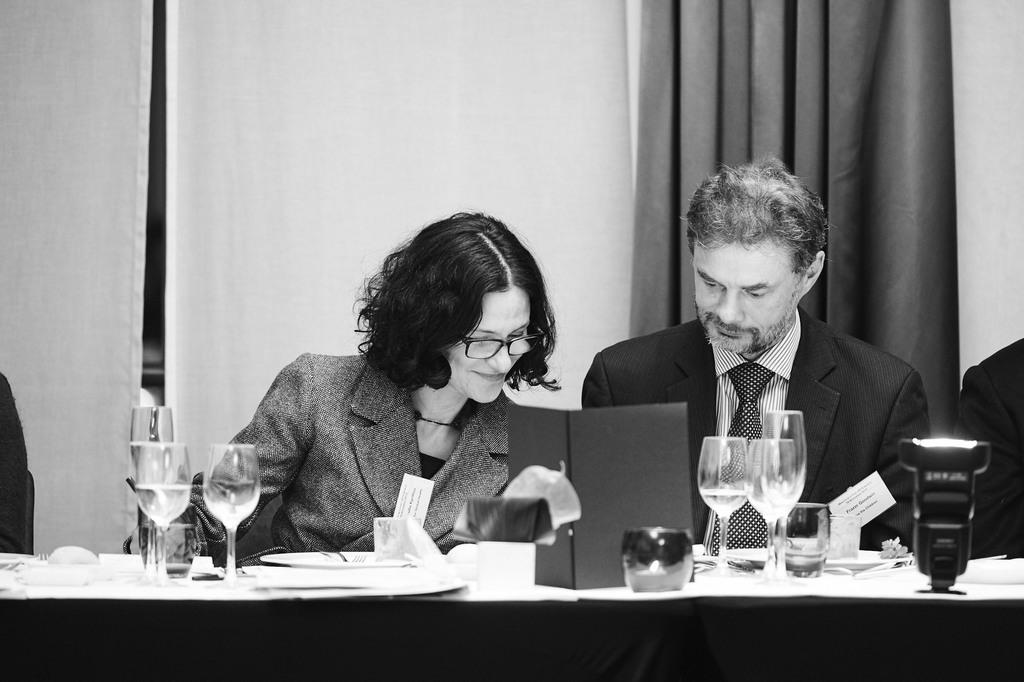How many people are in the image? There are two people in the image. What are the people doing in the image? The people are sitting on chairs. Where are the chairs located in relation to the table? The chairs are in front of a table. What can be seen on the table in the image? There are glasses and other things on the table. What type of brush is being used to put out the fire in the image? There is no fire or brush present in the image. 